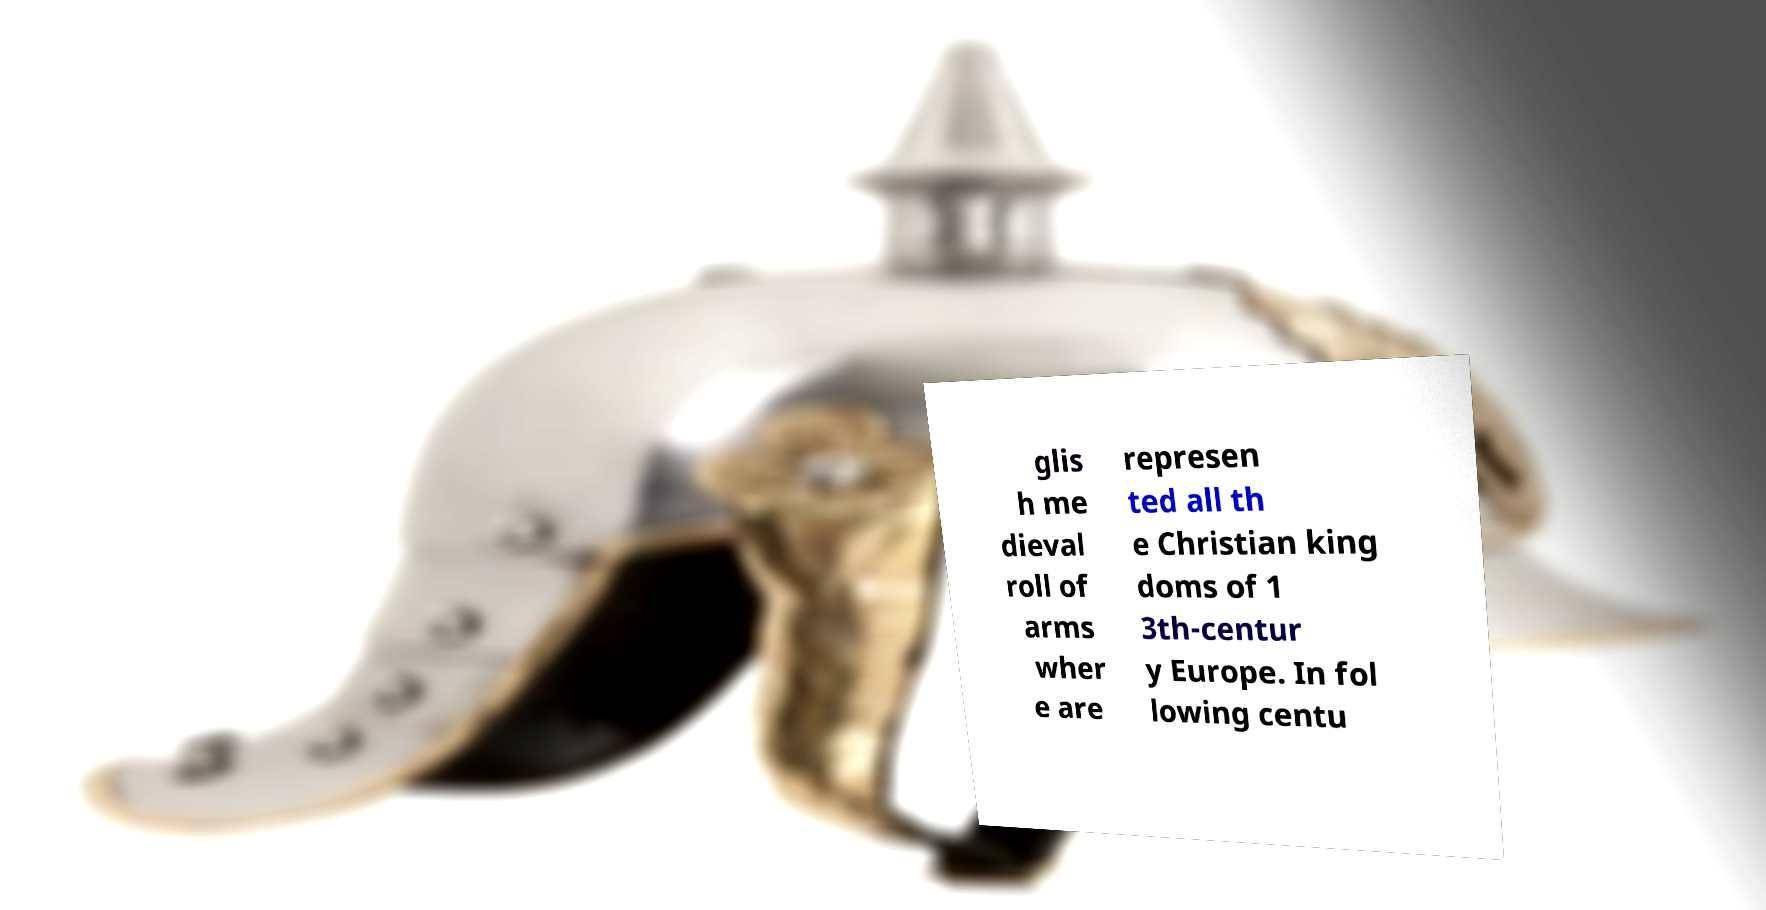Please read and relay the text visible in this image. What does it say? glis h me dieval roll of arms wher e are represen ted all th e Christian king doms of 1 3th-centur y Europe. In fol lowing centu 